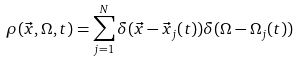<formula> <loc_0><loc_0><loc_500><loc_500>\rho ( \vec { x } , \Omega , t ) = \sum _ { j = 1 } ^ { N } \delta ( \vec { x } - \vec { x } _ { j } ( t ) ) \delta ( \Omega - \Omega _ { j } ( t ) )</formula> 